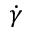Convert formula to latex. <formula><loc_0><loc_0><loc_500><loc_500>\dot { \gamma }</formula> 